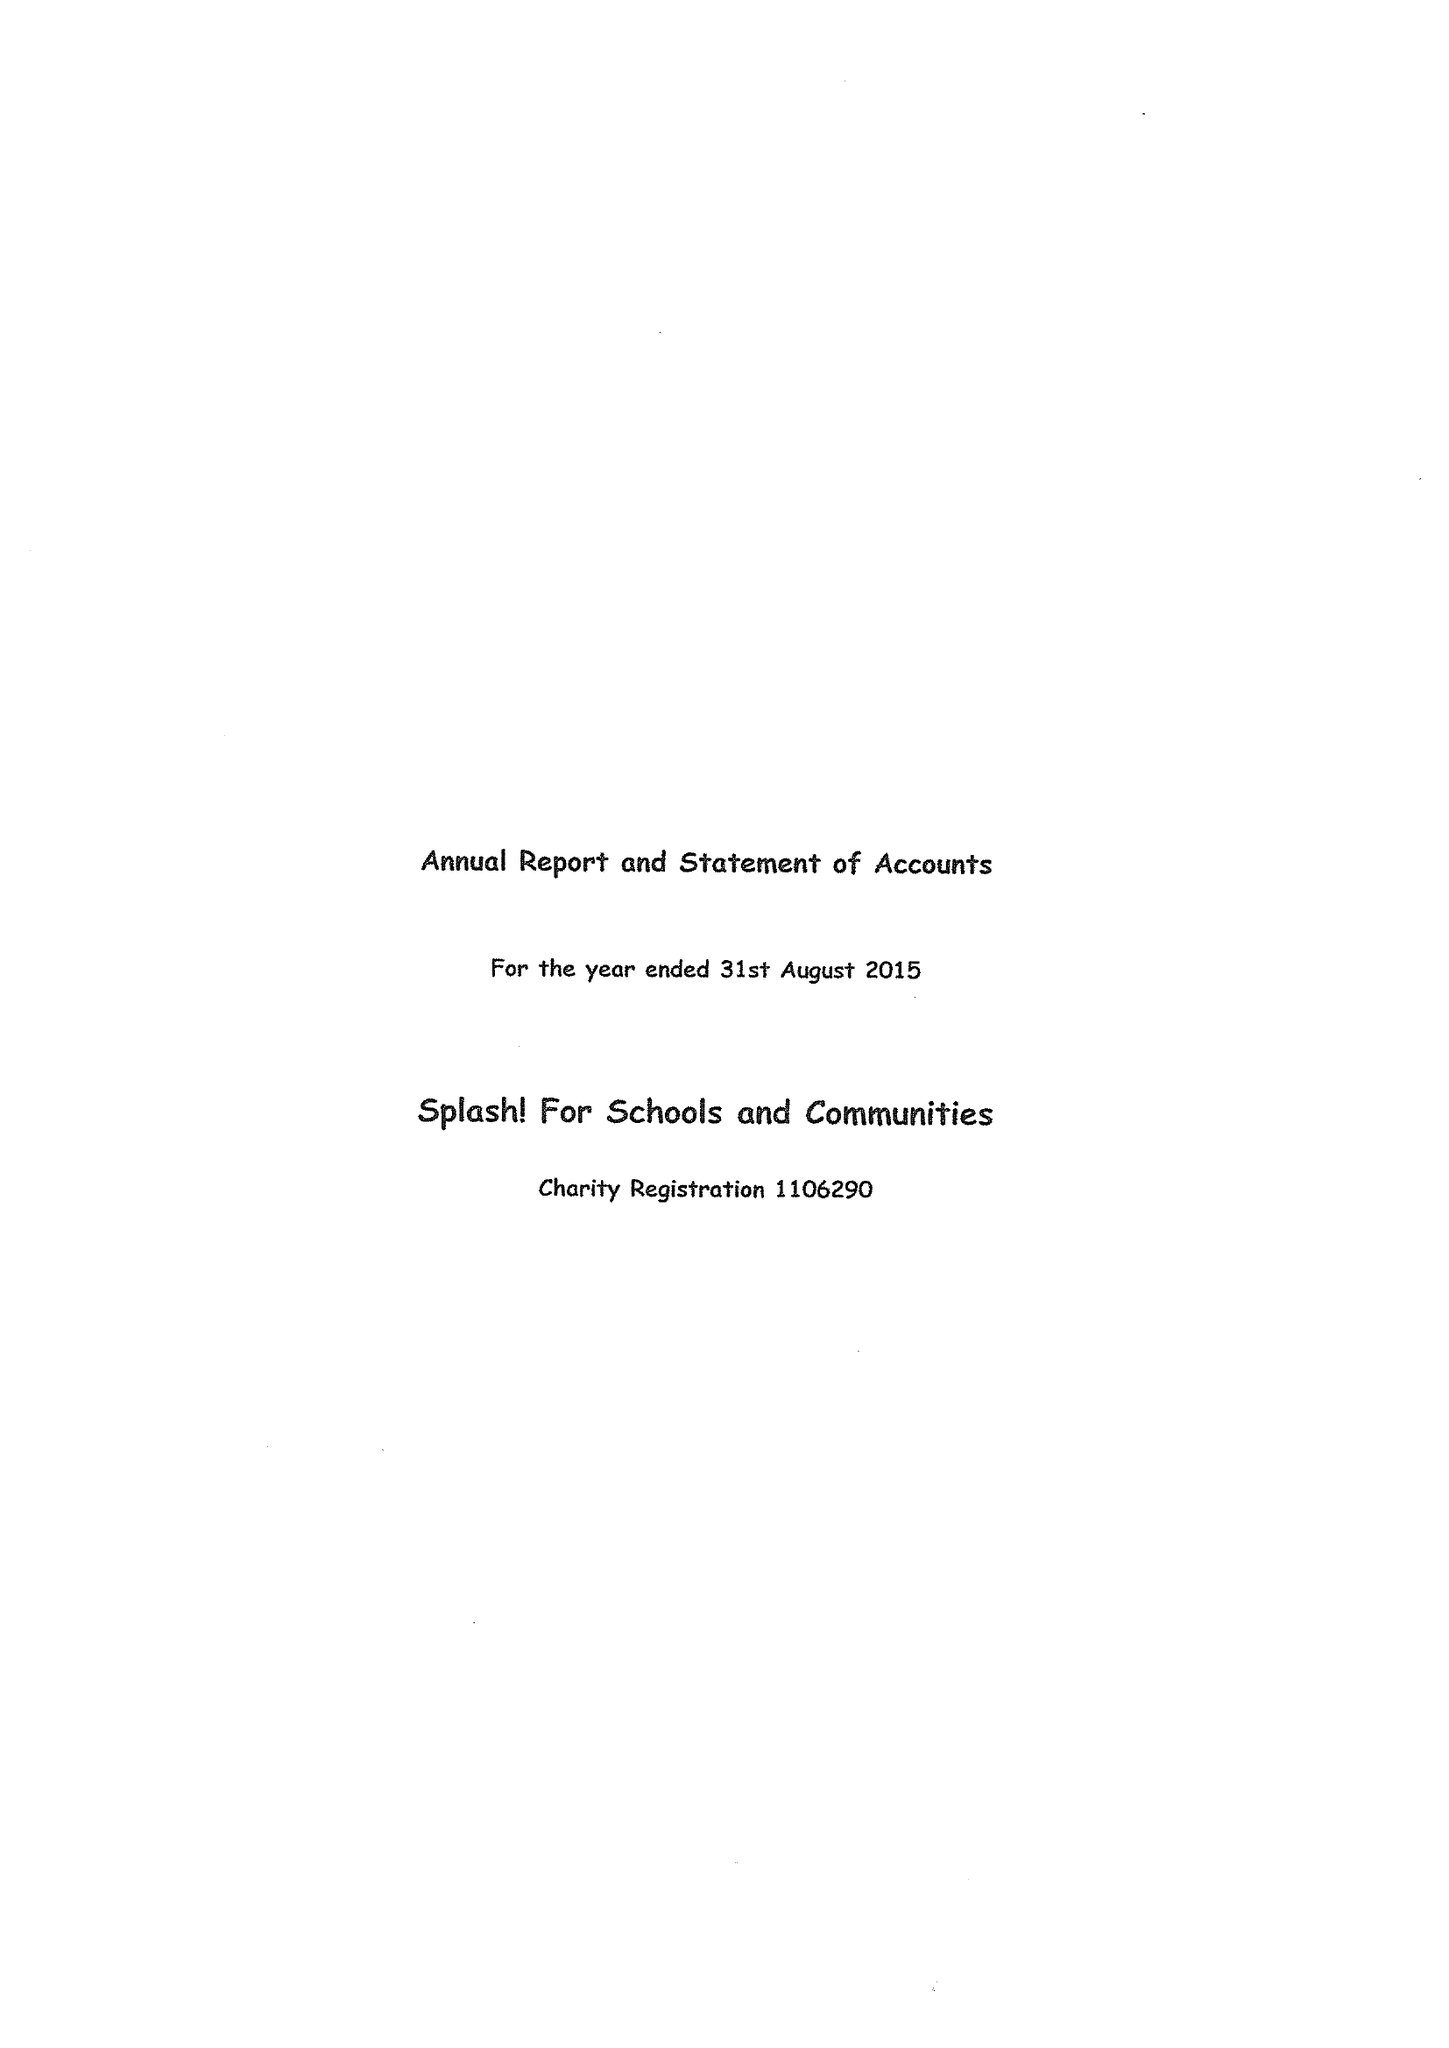What is the value for the charity_name?
Answer the question using a single word or phrase. Splash! For Schools and Communities 